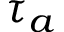Convert formula to latex. <formula><loc_0><loc_0><loc_500><loc_500>\tau _ { a }</formula> 